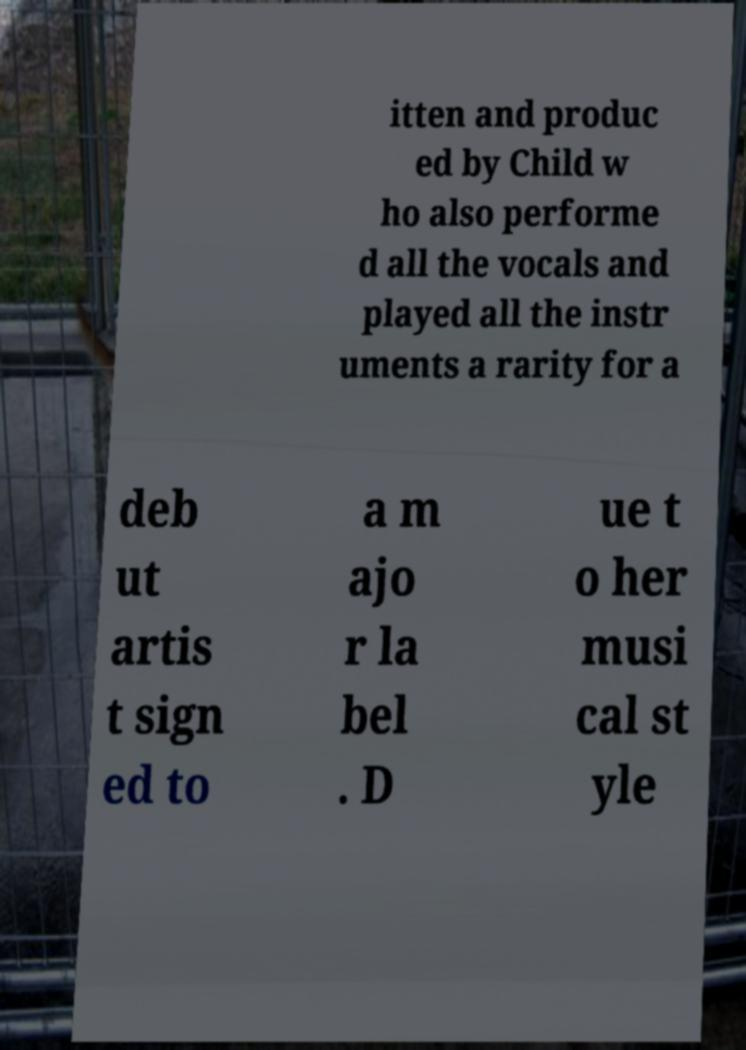Please identify and transcribe the text found in this image. itten and produc ed by Child w ho also performe d all the vocals and played all the instr uments a rarity for a deb ut artis t sign ed to a m ajo r la bel . D ue t o her musi cal st yle 